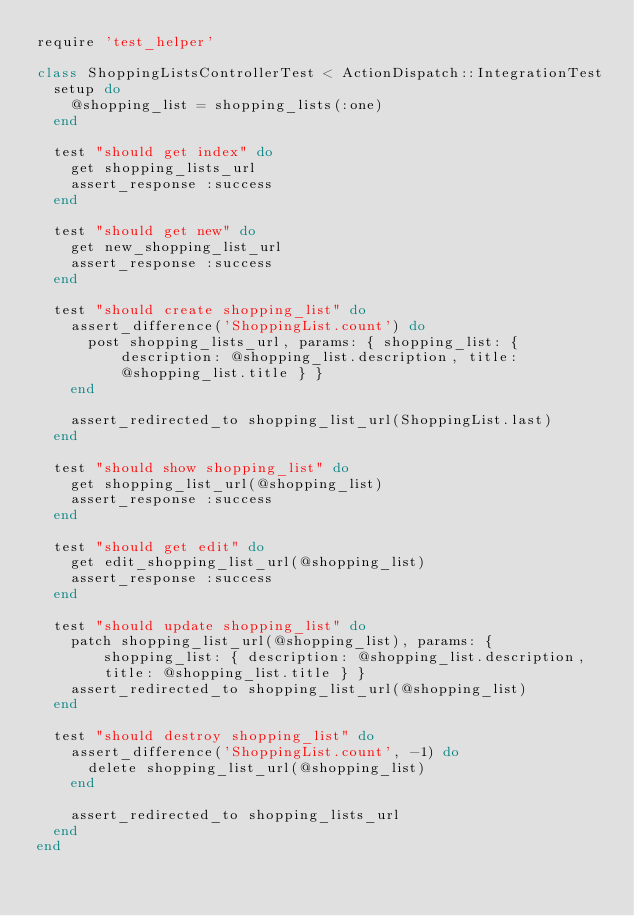<code> <loc_0><loc_0><loc_500><loc_500><_Ruby_>require 'test_helper'

class ShoppingListsControllerTest < ActionDispatch::IntegrationTest
  setup do
    @shopping_list = shopping_lists(:one)
  end

  test "should get index" do
    get shopping_lists_url
    assert_response :success
  end

  test "should get new" do
    get new_shopping_list_url
    assert_response :success
  end

  test "should create shopping_list" do
    assert_difference('ShoppingList.count') do
      post shopping_lists_url, params: { shopping_list: { description: @shopping_list.description, title: @shopping_list.title } }
    end

    assert_redirected_to shopping_list_url(ShoppingList.last)
  end

  test "should show shopping_list" do
    get shopping_list_url(@shopping_list)
    assert_response :success
  end

  test "should get edit" do
    get edit_shopping_list_url(@shopping_list)
    assert_response :success
  end

  test "should update shopping_list" do
    patch shopping_list_url(@shopping_list), params: { shopping_list: { description: @shopping_list.description, title: @shopping_list.title } }
    assert_redirected_to shopping_list_url(@shopping_list)
  end

  test "should destroy shopping_list" do
    assert_difference('ShoppingList.count', -1) do
      delete shopping_list_url(@shopping_list)
    end

    assert_redirected_to shopping_lists_url
  end
end
</code> 